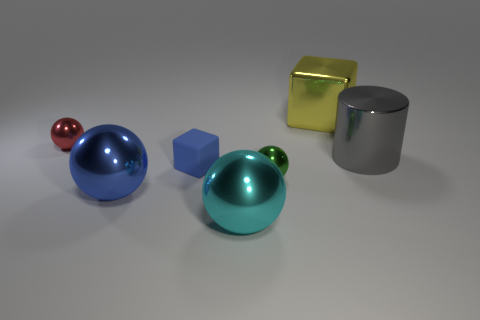Subtract all tiny red shiny balls. How many balls are left? 3 Subtract 1 spheres. How many spheres are left? 3 Subtract all cyan balls. How many balls are left? 3 Subtract all cyan spheres. Subtract all brown cylinders. How many spheres are left? 3 Add 2 green metallic things. How many objects exist? 9 Subtract all balls. How many objects are left? 3 Subtract all big objects. Subtract all tiny red balls. How many objects are left? 2 Add 4 gray metal things. How many gray metal things are left? 5 Add 5 big blue metal spheres. How many big blue metal spheres exist? 6 Subtract 0 yellow balls. How many objects are left? 7 